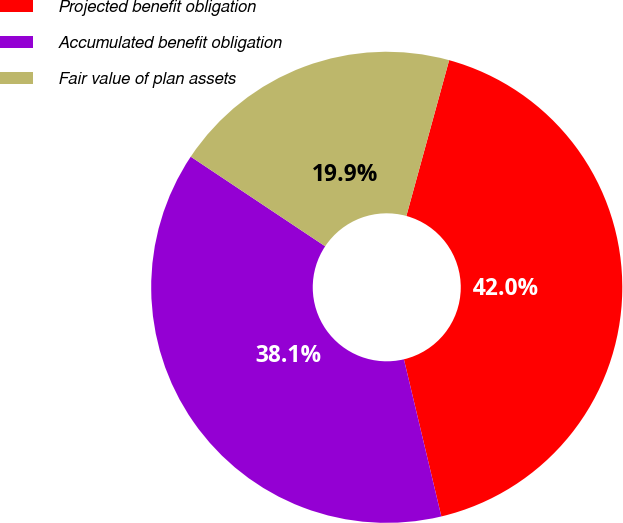Convert chart to OTSL. <chart><loc_0><loc_0><loc_500><loc_500><pie_chart><fcel>Projected benefit obligation<fcel>Accumulated benefit obligation<fcel>Fair value of plan assets<nl><fcel>42.01%<fcel>38.08%<fcel>19.91%<nl></chart> 